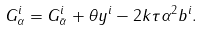<formula> <loc_0><loc_0><loc_500><loc_500>G ^ { i } _ { \alpha } = G ^ { i } _ { \bar { \alpha } } + \theta y ^ { i } - 2 k \tau \alpha ^ { 2 } b ^ { i } .</formula> 